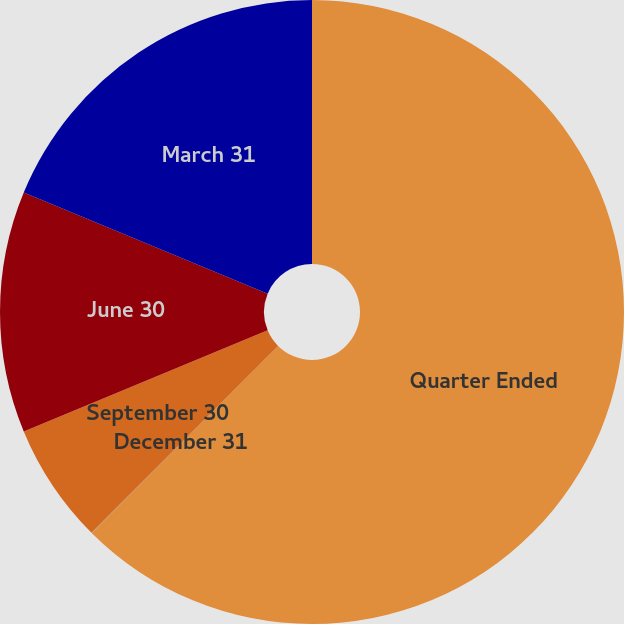Convert chart to OTSL. <chart><loc_0><loc_0><loc_500><loc_500><pie_chart><fcel>Quarter Ended<fcel>December 31<fcel>September 30<fcel>June 30<fcel>March 31<nl><fcel>62.48%<fcel>0.01%<fcel>6.26%<fcel>12.5%<fcel>18.75%<nl></chart> 